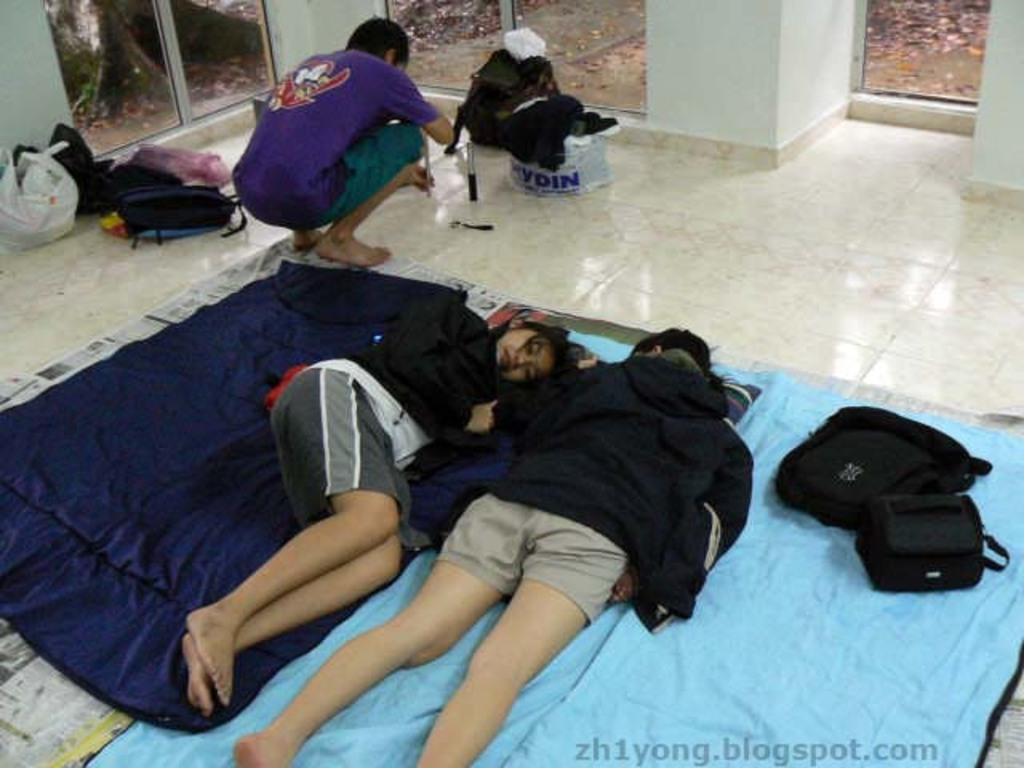<image>
Render a clear and concise summary of the photo. A picture of people sleeping is posted on someone's account on blogspot.com. 